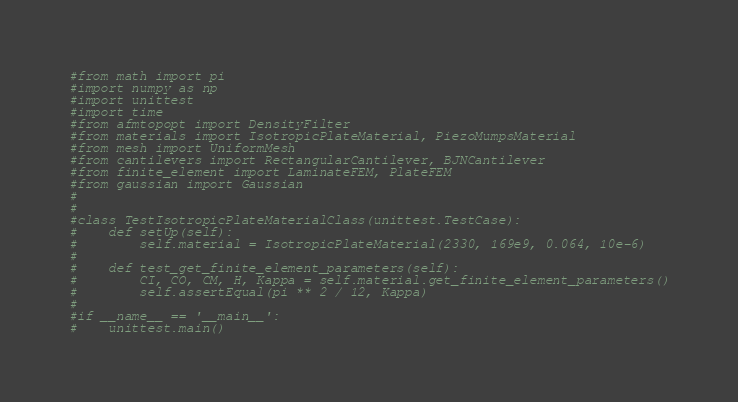Convert code to text. <code><loc_0><loc_0><loc_500><loc_500><_Python_>#from math import pi
#import numpy as np
#import unittest
#import time
#from afmtopopt import DensityFilter
#from materials import IsotropicPlateMaterial, PiezoMumpsMaterial
#from mesh import UniformMesh
#from cantilevers import RectangularCantilever, BJNCantilever
#from finite_element import LaminateFEM, PlateFEM
#from gaussian import Gaussian
#
#
#class TestIsotropicPlateMaterialClass(unittest.TestCase):
#    def setUp(self):
#        self.material = IsotropicPlateMaterial(2330, 169e9, 0.064, 10e-6)
# 
#    def test_get_finite_element_parameters(self):
#        CI, CO, CM, H, Kappa = self.material.get_finite_element_parameters()
#        self.assertEqual(pi ** 2 / 12, Kappa)
#        
#if __name__ == '__main__':
#    unittest.main()</code> 